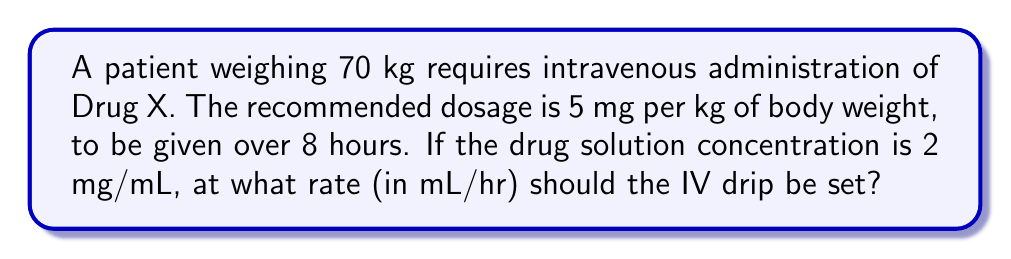Help me with this question. Let's break this down step-by-step:

1. Calculate the total drug dosage:
   $$\text{Total dosage} = \text{Patient weight} \times \text{Dosage per kg}$$
   $$\text{Total dosage} = 70 \text{ kg} \times 5 \text{ mg/kg} = 350 \text{ mg}$$

2. Convert the total dosage to volume:
   $$\text{Volume} = \frac{\text{Total dosage}}{\text{Drug concentration}}$$
   $$\text{Volume} = \frac{350 \text{ mg}}{2 \text{ mg/mL}} = 175 \text{ mL}$$

3. Calculate the hourly rate:
   $$\text{Hourly rate} = \frac{\text{Total volume}}{\text{Number of hours}}$$
   $$\text{Hourly rate} = \frac{175 \text{ mL}}{8 \text{ hours}} = 21.875 \text{ mL/hr}$$

Therefore, the IV drip should be set at 21.875 mL/hr.
Answer: 21.875 mL/hr 